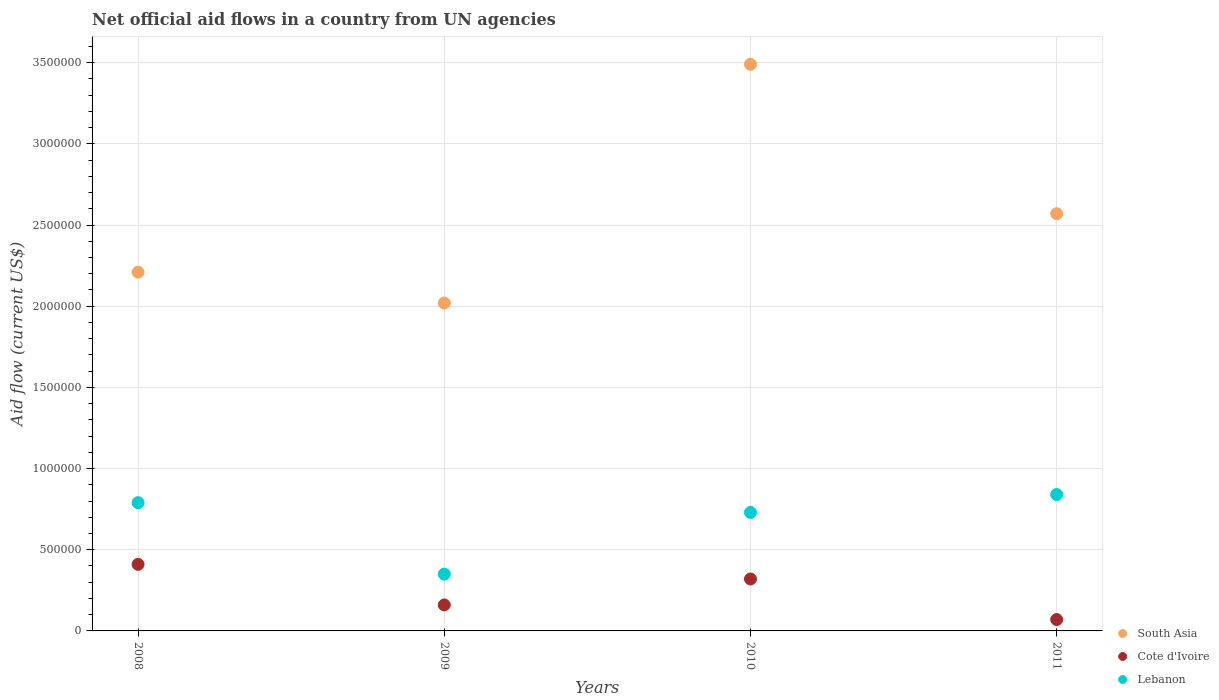What is the net official aid flow in Lebanon in 2010?
Your answer should be very brief. 7.30e+05. Across all years, what is the maximum net official aid flow in South Asia?
Provide a succinct answer. 3.49e+06. Across all years, what is the minimum net official aid flow in Cote d'Ivoire?
Keep it short and to the point. 7.00e+04. In which year was the net official aid flow in South Asia maximum?
Provide a succinct answer. 2010. What is the total net official aid flow in Cote d'Ivoire in the graph?
Offer a terse response. 9.60e+05. What is the difference between the net official aid flow in Cote d'Ivoire in 2010 and that in 2011?
Your answer should be compact. 2.50e+05. What is the difference between the net official aid flow in South Asia in 2011 and the net official aid flow in Lebanon in 2008?
Offer a terse response. 1.78e+06. What is the average net official aid flow in Lebanon per year?
Your answer should be very brief. 6.78e+05. In the year 2009, what is the difference between the net official aid flow in Lebanon and net official aid flow in Cote d'Ivoire?
Keep it short and to the point. 1.90e+05. In how many years, is the net official aid flow in Lebanon greater than 1100000 US$?
Keep it short and to the point. 0. What is the ratio of the net official aid flow in Lebanon in 2008 to that in 2010?
Ensure brevity in your answer.  1.08. Is the net official aid flow in South Asia in 2009 less than that in 2011?
Make the answer very short. Yes. Is the difference between the net official aid flow in Lebanon in 2010 and 2011 greater than the difference between the net official aid flow in Cote d'Ivoire in 2010 and 2011?
Your response must be concise. No. What is the difference between the highest and the second highest net official aid flow in South Asia?
Ensure brevity in your answer.  9.20e+05. What is the difference between the highest and the lowest net official aid flow in Cote d'Ivoire?
Offer a very short reply. 3.40e+05. In how many years, is the net official aid flow in South Asia greater than the average net official aid flow in South Asia taken over all years?
Provide a succinct answer. 1. Does the net official aid flow in Lebanon monotonically increase over the years?
Offer a terse response. No. Is the net official aid flow in South Asia strictly greater than the net official aid flow in Lebanon over the years?
Offer a terse response. Yes. Is the net official aid flow in Lebanon strictly less than the net official aid flow in South Asia over the years?
Make the answer very short. Yes. How many years are there in the graph?
Keep it short and to the point. 4. Are the values on the major ticks of Y-axis written in scientific E-notation?
Ensure brevity in your answer.  No. Does the graph contain any zero values?
Keep it short and to the point. No. Does the graph contain grids?
Make the answer very short. Yes. What is the title of the graph?
Your answer should be compact. Net official aid flows in a country from UN agencies. What is the label or title of the X-axis?
Your answer should be compact. Years. What is the Aid flow (current US$) in South Asia in 2008?
Your response must be concise. 2.21e+06. What is the Aid flow (current US$) of Cote d'Ivoire in 2008?
Your answer should be compact. 4.10e+05. What is the Aid flow (current US$) of Lebanon in 2008?
Make the answer very short. 7.90e+05. What is the Aid flow (current US$) of South Asia in 2009?
Provide a succinct answer. 2.02e+06. What is the Aid flow (current US$) in Lebanon in 2009?
Give a very brief answer. 3.50e+05. What is the Aid flow (current US$) of South Asia in 2010?
Ensure brevity in your answer.  3.49e+06. What is the Aid flow (current US$) in Lebanon in 2010?
Provide a succinct answer. 7.30e+05. What is the Aid flow (current US$) of South Asia in 2011?
Ensure brevity in your answer.  2.57e+06. What is the Aid flow (current US$) of Lebanon in 2011?
Keep it short and to the point. 8.40e+05. Across all years, what is the maximum Aid flow (current US$) of South Asia?
Offer a terse response. 3.49e+06. Across all years, what is the maximum Aid flow (current US$) in Cote d'Ivoire?
Give a very brief answer. 4.10e+05. Across all years, what is the maximum Aid flow (current US$) of Lebanon?
Keep it short and to the point. 8.40e+05. Across all years, what is the minimum Aid flow (current US$) in South Asia?
Your response must be concise. 2.02e+06. Across all years, what is the minimum Aid flow (current US$) of Cote d'Ivoire?
Ensure brevity in your answer.  7.00e+04. Across all years, what is the minimum Aid flow (current US$) in Lebanon?
Make the answer very short. 3.50e+05. What is the total Aid flow (current US$) in South Asia in the graph?
Your response must be concise. 1.03e+07. What is the total Aid flow (current US$) in Cote d'Ivoire in the graph?
Give a very brief answer. 9.60e+05. What is the total Aid flow (current US$) of Lebanon in the graph?
Ensure brevity in your answer.  2.71e+06. What is the difference between the Aid flow (current US$) in South Asia in 2008 and that in 2009?
Offer a terse response. 1.90e+05. What is the difference between the Aid flow (current US$) of Cote d'Ivoire in 2008 and that in 2009?
Your answer should be compact. 2.50e+05. What is the difference between the Aid flow (current US$) in South Asia in 2008 and that in 2010?
Give a very brief answer. -1.28e+06. What is the difference between the Aid flow (current US$) of Cote d'Ivoire in 2008 and that in 2010?
Your answer should be very brief. 9.00e+04. What is the difference between the Aid flow (current US$) of Lebanon in 2008 and that in 2010?
Ensure brevity in your answer.  6.00e+04. What is the difference between the Aid flow (current US$) of South Asia in 2008 and that in 2011?
Give a very brief answer. -3.60e+05. What is the difference between the Aid flow (current US$) in Cote d'Ivoire in 2008 and that in 2011?
Make the answer very short. 3.40e+05. What is the difference between the Aid flow (current US$) in South Asia in 2009 and that in 2010?
Provide a short and direct response. -1.47e+06. What is the difference between the Aid flow (current US$) of Lebanon in 2009 and that in 2010?
Your answer should be very brief. -3.80e+05. What is the difference between the Aid flow (current US$) in South Asia in 2009 and that in 2011?
Your answer should be very brief. -5.50e+05. What is the difference between the Aid flow (current US$) in Cote d'Ivoire in 2009 and that in 2011?
Make the answer very short. 9.00e+04. What is the difference between the Aid flow (current US$) in Lebanon in 2009 and that in 2011?
Your answer should be compact. -4.90e+05. What is the difference between the Aid flow (current US$) in South Asia in 2010 and that in 2011?
Keep it short and to the point. 9.20e+05. What is the difference between the Aid flow (current US$) of South Asia in 2008 and the Aid flow (current US$) of Cote d'Ivoire in 2009?
Provide a short and direct response. 2.05e+06. What is the difference between the Aid flow (current US$) of South Asia in 2008 and the Aid flow (current US$) of Lebanon in 2009?
Provide a succinct answer. 1.86e+06. What is the difference between the Aid flow (current US$) of Cote d'Ivoire in 2008 and the Aid flow (current US$) of Lebanon in 2009?
Your answer should be very brief. 6.00e+04. What is the difference between the Aid flow (current US$) of South Asia in 2008 and the Aid flow (current US$) of Cote d'Ivoire in 2010?
Keep it short and to the point. 1.89e+06. What is the difference between the Aid flow (current US$) in South Asia in 2008 and the Aid flow (current US$) in Lebanon in 2010?
Provide a short and direct response. 1.48e+06. What is the difference between the Aid flow (current US$) in Cote d'Ivoire in 2008 and the Aid flow (current US$) in Lebanon in 2010?
Keep it short and to the point. -3.20e+05. What is the difference between the Aid flow (current US$) of South Asia in 2008 and the Aid flow (current US$) of Cote d'Ivoire in 2011?
Your answer should be compact. 2.14e+06. What is the difference between the Aid flow (current US$) in South Asia in 2008 and the Aid flow (current US$) in Lebanon in 2011?
Keep it short and to the point. 1.37e+06. What is the difference between the Aid flow (current US$) in Cote d'Ivoire in 2008 and the Aid flow (current US$) in Lebanon in 2011?
Provide a succinct answer. -4.30e+05. What is the difference between the Aid flow (current US$) of South Asia in 2009 and the Aid flow (current US$) of Cote d'Ivoire in 2010?
Your answer should be compact. 1.70e+06. What is the difference between the Aid flow (current US$) in South Asia in 2009 and the Aid flow (current US$) in Lebanon in 2010?
Make the answer very short. 1.29e+06. What is the difference between the Aid flow (current US$) of Cote d'Ivoire in 2009 and the Aid flow (current US$) of Lebanon in 2010?
Your response must be concise. -5.70e+05. What is the difference between the Aid flow (current US$) of South Asia in 2009 and the Aid flow (current US$) of Cote d'Ivoire in 2011?
Your response must be concise. 1.95e+06. What is the difference between the Aid flow (current US$) in South Asia in 2009 and the Aid flow (current US$) in Lebanon in 2011?
Make the answer very short. 1.18e+06. What is the difference between the Aid flow (current US$) in Cote d'Ivoire in 2009 and the Aid flow (current US$) in Lebanon in 2011?
Provide a short and direct response. -6.80e+05. What is the difference between the Aid flow (current US$) of South Asia in 2010 and the Aid flow (current US$) of Cote d'Ivoire in 2011?
Offer a terse response. 3.42e+06. What is the difference between the Aid flow (current US$) in South Asia in 2010 and the Aid flow (current US$) in Lebanon in 2011?
Offer a very short reply. 2.65e+06. What is the difference between the Aid flow (current US$) in Cote d'Ivoire in 2010 and the Aid flow (current US$) in Lebanon in 2011?
Offer a terse response. -5.20e+05. What is the average Aid flow (current US$) of South Asia per year?
Your answer should be very brief. 2.57e+06. What is the average Aid flow (current US$) of Lebanon per year?
Give a very brief answer. 6.78e+05. In the year 2008, what is the difference between the Aid flow (current US$) of South Asia and Aid flow (current US$) of Cote d'Ivoire?
Keep it short and to the point. 1.80e+06. In the year 2008, what is the difference between the Aid flow (current US$) of South Asia and Aid flow (current US$) of Lebanon?
Your answer should be very brief. 1.42e+06. In the year 2008, what is the difference between the Aid flow (current US$) of Cote d'Ivoire and Aid flow (current US$) of Lebanon?
Your response must be concise. -3.80e+05. In the year 2009, what is the difference between the Aid flow (current US$) in South Asia and Aid flow (current US$) in Cote d'Ivoire?
Offer a very short reply. 1.86e+06. In the year 2009, what is the difference between the Aid flow (current US$) in South Asia and Aid flow (current US$) in Lebanon?
Your answer should be very brief. 1.67e+06. In the year 2009, what is the difference between the Aid flow (current US$) of Cote d'Ivoire and Aid flow (current US$) of Lebanon?
Give a very brief answer. -1.90e+05. In the year 2010, what is the difference between the Aid flow (current US$) of South Asia and Aid flow (current US$) of Cote d'Ivoire?
Provide a short and direct response. 3.17e+06. In the year 2010, what is the difference between the Aid flow (current US$) of South Asia and Aid flow (current US$) of Lebanon?
Ensure brevity in your answer.  2.76e+06. In the year 2010, what is the difference between the Aid flow (current US$) of Cote d'Ivoire and Aid flow (current US$) of Lebanon?
Ensure brevity in your answer.  -4.10e+05. In the year 2011, what is the difference between the Aid flow (current US$) of South Asia and Aid flow (current US$) of Cote d'Ivoire?
Give a very brief answer. 2.50e+06. In the year 2011, what is the difference between the Aid flow (current US$) in South Asia and Aid flow (current US$) in Lebanon?
Provide a short and direct response. 1.73e+06. In the year 2011, what is the difference between the Aid flow (current US$) in Cote d'Ivoire and Aid flow (current US$) in Lebanon?
Your answer should be very brief. -7.70e+05. What is the ratio of the Aid flow (current US$) in South Asia in 2008 to that in 2009?
Give a very brief answer. 1.09. What is the ratio of the Aid flow (current US$) of Cote d'Ivoire in 2008 to that in 2009?
Provide a short and direct response. 2.56. What is the ratio of the Aid flow (current US$) in Lebanon in 2008 to that in 2009?
Make the answer very short. 2.26. What is the ratio of the Aid flow (current US$) of South Asia in 2008 to that in 2010?
Make the answer very short. 0.63. What is the ratio of the Aid flow (current US$) of Cote d'Ivoire in 2008 to that in 2010?
Provide a short and direct response. 1.28. What is the ratio of the Aid flow (current US$) in Lebanon in 2008 to that in 2010?
Provide a short and direct response. 1.08. What is the ratio of the Aid flow (current US$) in South Asia in 2008 to that in 2011?
Keep it short and to the point. 0.86. What is the ratio of the Aid flow (current US$) in Cote d'Ivoire in 2008 to that in 2011?
Offer a terse response. 5.86. What is the ratio of the Aid flow (current US$) in Lebanon in 2008 to that in 2011?
Offer a terse response. 0.94. What is the ratio of the Aid flow (current US$) of South Asia in 2009 to that in 2010?
Provide a short and direct response. 0.58. What is the ratio of the Aid flow (current US$) of Lebanon in 2009 to that in 2010?
Offer a terse response. 0.48. What is the ratio of the Aid flow (current US$) of South Asia in 2009 to that in 2011?
Provide a succinct answer. 0.79. What is the ratio of the Aid flow (current US$) of Cote d'Ivoire in 2009 to that in 2011?
Offer a terse response. 2.29. What is the ratio of the Aid flow (current US$) in Lebanon in 2009 to that in 2011?
Your answer should be very brief. 0.42. What is the ratio of the Aid flow (current US$) in South Asia in 2010 to that in 2011?
Ensure brevity in your answer.  1.36. What is the ratio of the Aid flow (current US$) of Cote d'Ivoire in 2010 to that in 2011?
Offer a terse response. 4.57. What is the ratio of the Aid flow (current US$) of Lebanon in 2010 to that in 2011?
Give a very brief answer. 0.87. What is the difference between the highest and the second highest Aid flow (current US$) in South Asia?
Provide a short and direct response. 9.20e+05. What is the difference between the highest and the second highest Aid flow (current US$) in Cote d'Ivoire?
Your response must be concise. 9.00e+04. What is the difference between the highest and the lowest Aid flow (current US$) of South Asia?
Offer a very short reply. 1.47e+06. What is the difference between the highest and the lowest Aid flow (current US$) of Cote d'Ivoire?
Give a very brief answer. 3.40e+05. What is the difference between the highest and the lowest Aid flow (current US$) in Lebanon?
Your answer should be compact. 4.90e+05. 